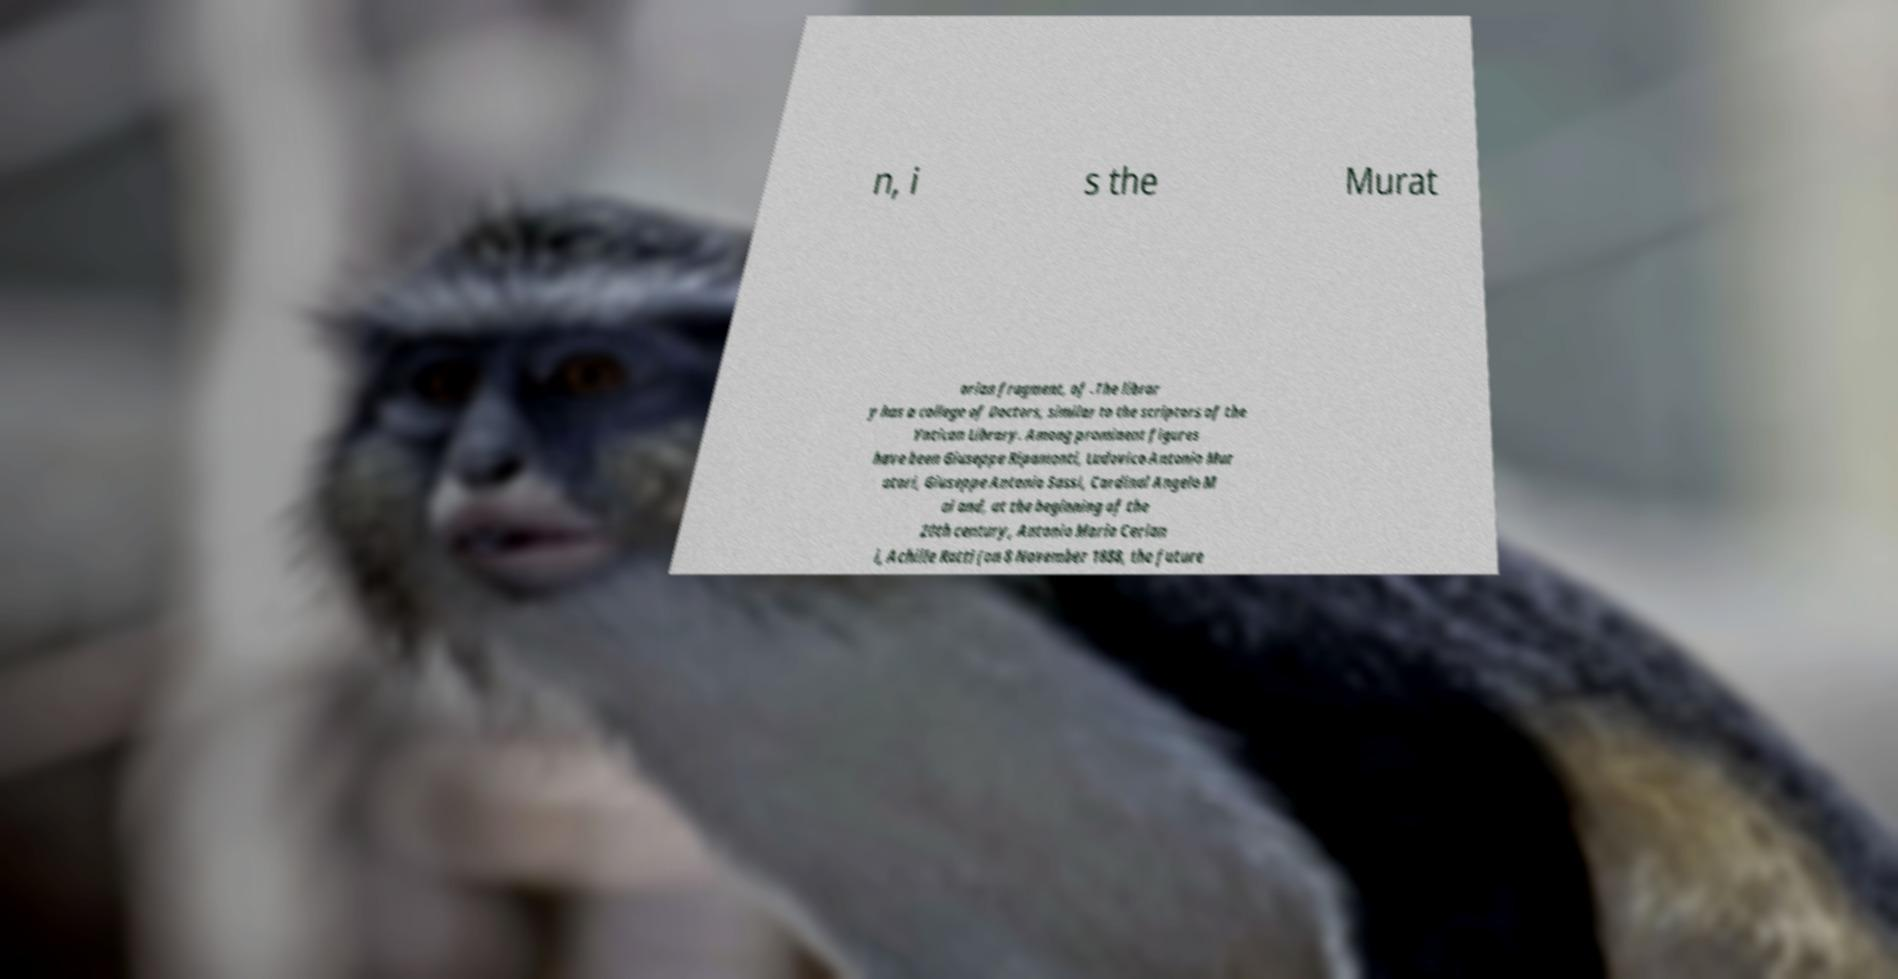For documentation purposes, I need the text within this image transcribed. Could you provide that? n, i s the Murat orian fragment, of .The librar y has a college of Doctors, similar to the scriptors of the Vatican Library. Among prominent figures have been Giuseppe Ripamonti, Ludovico Antonio Mur atori, Giuseppe Antonio Sassi, Cardinal Angelo M ai and, at the beginning of the 20th century, Antonio Maria Cerian i, Achille Ratti (on 8 November 1888, the future 